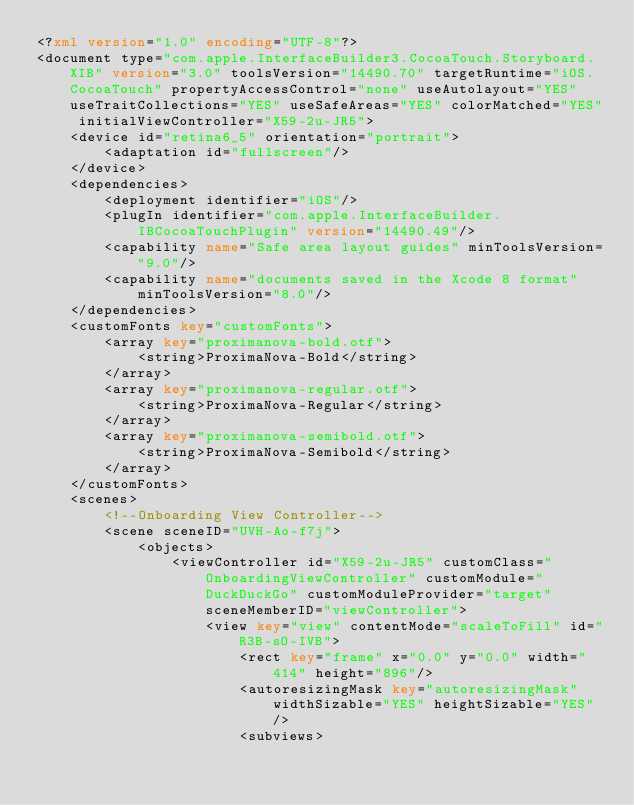<code> <loc_0><loc_0><loc_500><loc_500><_XML_><?xml version="1.0" encoding="UTF-8"?>
<document type="com.apple.InterfaceBuilder3.CocoaTouch.Storyboard.XIB" version="3.0" toolsVersion="14490.70" targetRuntime="iOS.CocoaTouch" propertyAccessControl="none" useAutolayout="YES" useTraitCollections="YES" useSafeAreas="YES" colorMatched="YES" initialViewController="X59-2u-JR5">
    <device id="retina6_5" orientation="portrait">
        <adaptation id="fullscreen"/>
    </device>
    <dependencies>
        <deployment identifier="iOS"/>
        <plugIn identifier="com.apple.InterfaceBuilder.IBCocoaTouchPlugin" version="14490.49"/>
        <capability name="Safe area layout guides" minToolsVersion="9.0"/>
        <capability name="documents saved in the Xcode 8 format" minToolsVersion="8.0"/>
    </dependencies>
    <customFonts key="customFonts">
        <array key="proximanova-bold.otf">
            <string>ProximaNova-Bold</string>
        </array>
        <array key="proximanova-regular.otf">
            <string>ProximaNova-Regular</string>
        </array>
        <array key="proximanova-semibold.otf">
            <string>ProximaNova-Semibold</string>
        </array>
    </customFonts>
    <scenes>
        <!--Onboarding View Controller-->
        <scene sceneID="UVH-Ao-f7j">
            <objects>
                <viewController id="X59-2u-JR5" customClass="OnboardingViewController" customModule="DuckDuckGo" customModuleProvider="target" sceneMemberID="viewController">
                    <view key="view" contentMode="scaleToFill" id="R3B-sO-IVB">
                        <rect key="frame" x="0.0" y="0.0" width="414" height="896"/>
                        <autoresizingMask key="autoresizingMask" widthSizable="YES" heightSizable="YES"/>
                        <subviews></code> 